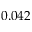Convert formula to latex. <formula><loc_0><loc_0><loc_500><loc_500>0 . 0 4 2</formula> 